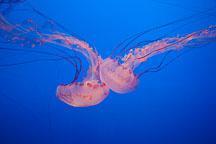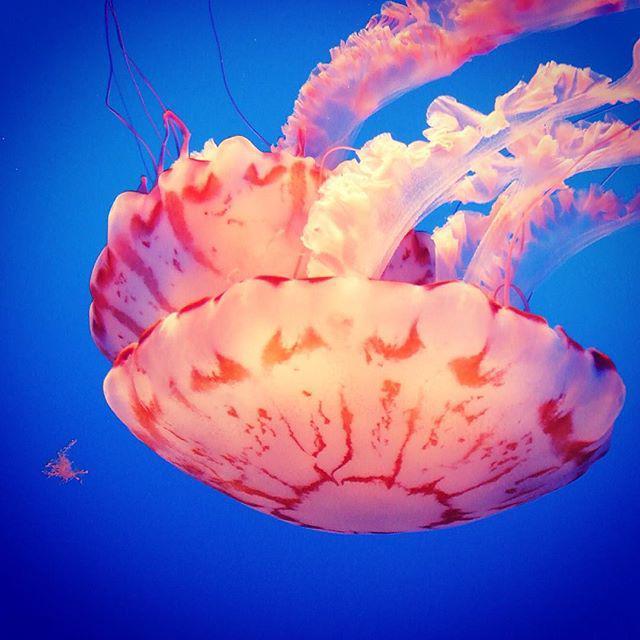The first image is the image on the left, the second image is the image on the right. For the images shown, is this caption "There are three jellyfish in total." true? Answer yes or no. No. 